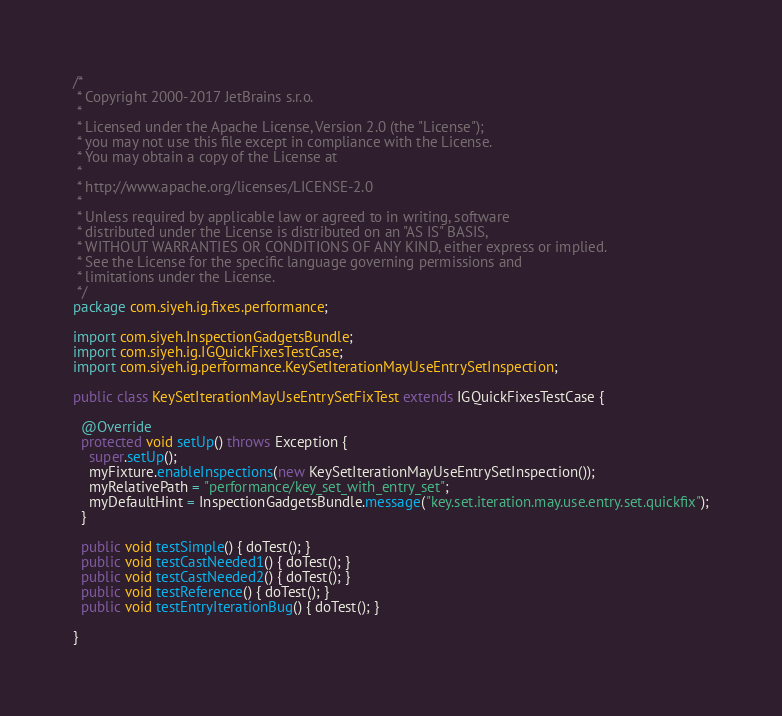Convert code to text. <code><loc_0><loc_0><loc_500><loc_500><_Java_>/*
 * Copyright 2000-2017 JetBrains s.r.o.
 *
 * Licensed under the Apache License, Version 2.0 (the "License");
 * you may not use this file except in compliance with the License.
 * You may obtain a copy of the License at
 *
 * http://www.apache.org/licenses/LICENSE-2.0
 *
 * Unless required by applicable law or agreed to in writing, software
 * distributed under the License is distributed on an "AS IS" BASIS,
 * WITHOUT WARRANTIES OR CONDITIONS OF ANY KIND, either express or implied.
 * See the License for the specific language governing permissions and
 * limitations under the License.
 */
package com.siyeh.ig.fixes.performance;

import com.siyeh.InspectionGadgetsBundle;
import com.siyeh.ig.IGQuickFixesTestCase;
import com.siyeh.ig.performance.KeySetIterationMayUseEntrySetInspection;

public class KeySetIterationMayUseEntrySetFixTest extends IGQuickFixesTestCase {

  @Override
  protected void setUp() throws Exception {
    super.setUp();
    myFixture.enableInspections(new KeySetIterationMayUseEntrySetInspection());
    myRelativePath = "performance/key_set_with_entry_set";
    myDefaultHint = InspectionGadgetsBundle.message("key.set.iteration.may.use.entry.set.quickfix");
  }

  public void testSimple() { doTest(); }
  public void testCastNeeded1() { doTest(); }
  public void testCastNeeded2() { doTest(); }
  public void testReference() { doTest(); }
  public void testEntryIterationBug() { doTest(); }

}</code> 